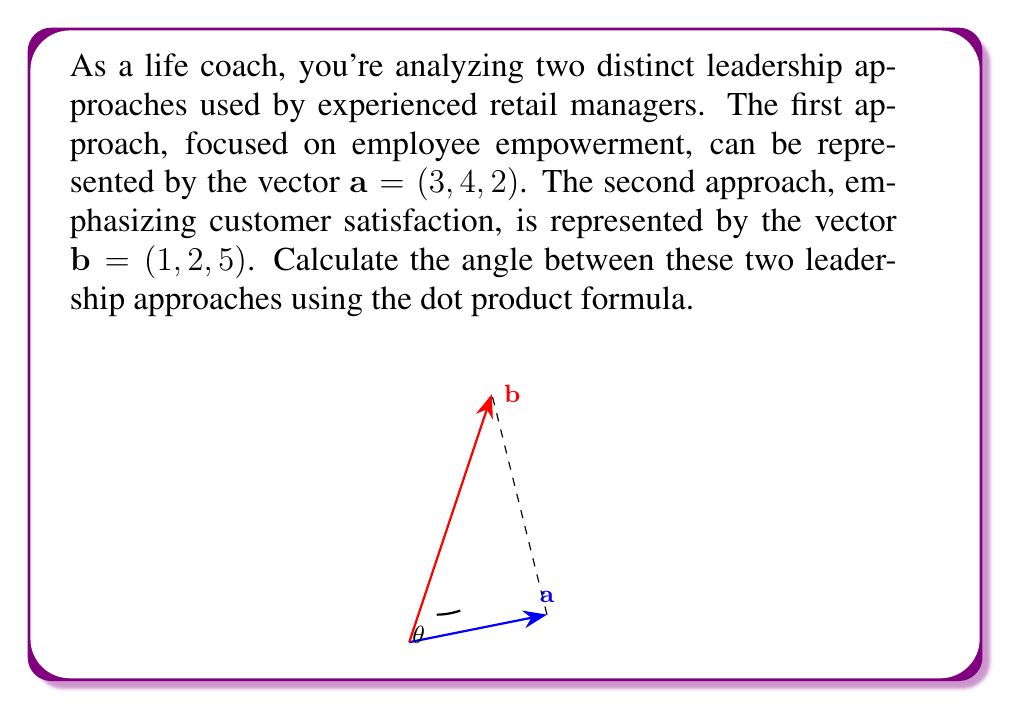Help me with this question. To find the angle between two vectors using the dot product, we'll follow these steps:

1) The formula for the angle $\theta$ between two vectors $\mathbf{a}$ and $\mathbf{b}$ is:

   $$\cos\theta = \frac{\mathbf{a} \cdot \mathbf{b}}{|\mathbf{a}||\mathbf{b}|}$$

2) Calculate the dot product $\mathbf{a} \cdot \mathbf{b}$:
   $$\mathbf{a} \cdot \mathbf{b} = (3)(1) + (4)(2) + (2)(5) = 3 + 8 + 10 = 21$$

3) Calculate the magnitudes of the vectors:
   $$|\mathbf{a}| = \sqrt{3^2 + 4^2 + 2^2} = \sqrt{9 + 16 + 4} = \sqrt{29}$$
   $$|\mathbf{b}| = \sqrt{1^2 + 2^2 + 5^2} = \sqrt{1 + 4 + 25} = \sqrt{30}$$

4) Substitute into the formula:
   $$\cos\theta = \frac{21}{\sqrt{29}\sqrt{30}}$$

5) Simplify:
   $$\cos\theta = \frac{21}{\sqrt{870}}$$

6) Take the inverse cosine (arccos) of both sides:
   $$\theta = \arccos\left(\frac{21}{\sqrt{870}}\right)$$

7) Calculate the result (rounded to two decimal places):
   $$\theta \approx 0.78 \text{ radians} \approx 44.71°$$
Answer: $44.71°$ 